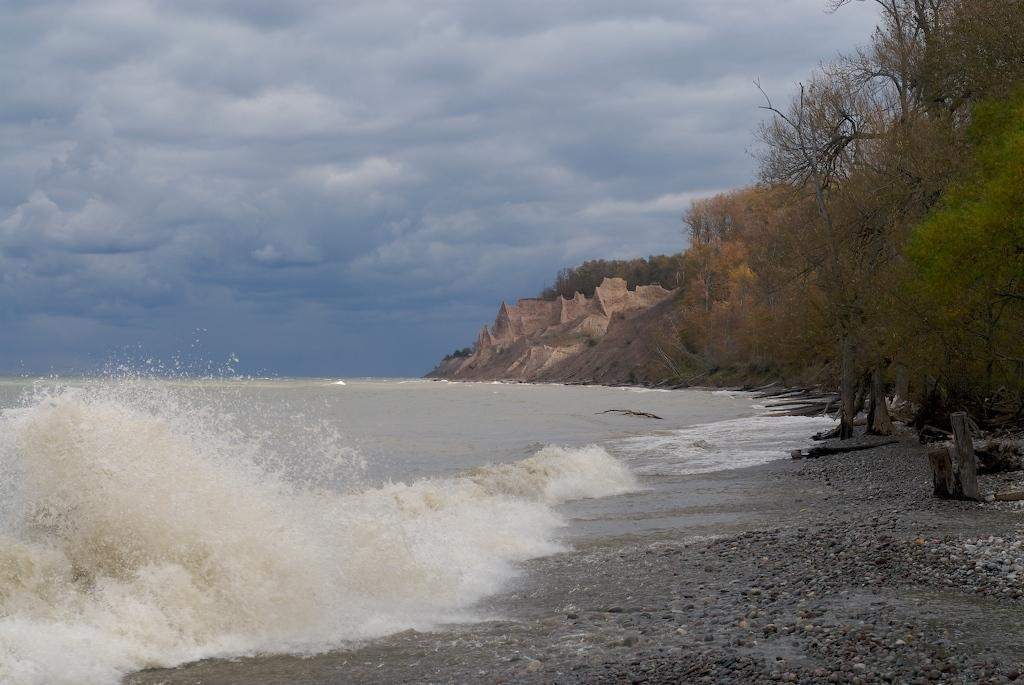What type of natural feature is on the left side of the image? There is the sea on the left side of the image. What type of vegetation is on the right side of the image? There are trees on the right side of the image. What is the condition of the sky in the image? The sky is cloudy and visible at the top of the image. What type of shoes can be seen crushed under the trees in the image? There are no shoes present in the image, and therefore no shoes can be seen crushed under the trees. 